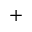Convert formula to latex. <formula><loc_0><loc_0><loc_500><loc_500>^ { + }</formula> 